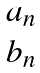Convert formula to latex. <formula><loc_0><loc_0><loc_500><loc_500>\begin{matrix} a _ { n } \\ b _ { n } \end{matrix}</formula> 